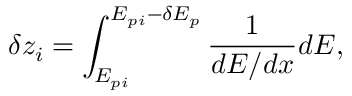Convert formula to latex. <formula><loc_0><loc_0><loc_500><loc_500>\delta z _ { i } = \int _ { E _ { p i } } ^ { E _ { p i } - \delta E _ { p } } \frac { 1 } { d E / d x } d E ,</formula> 